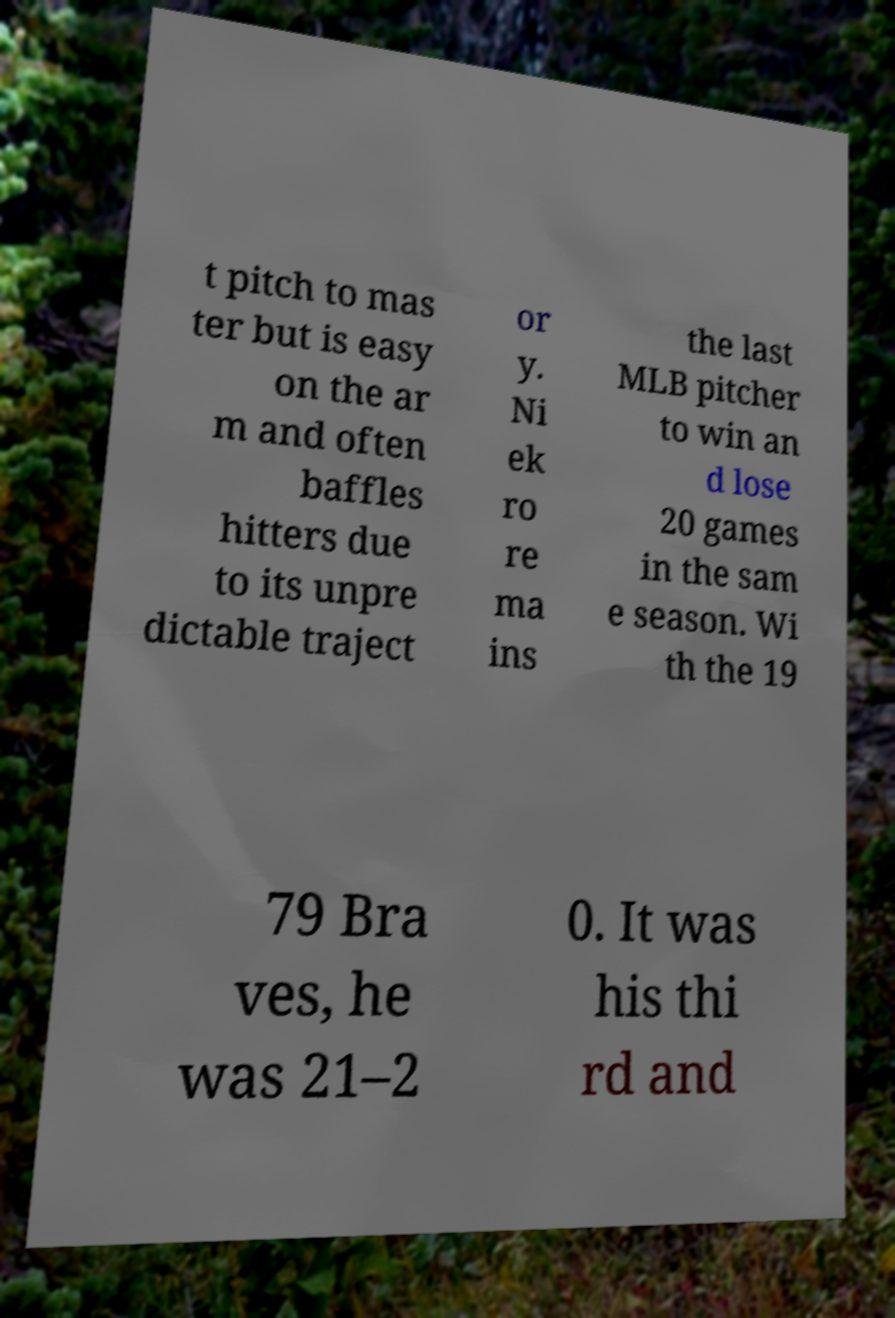What messages or text are displayed in this image? I need them in a readable, typed format. t pitch to mas ter but is easy on the ar m and often baffles hitters due to its unpre dictable traject or y. Ni ek ro re ma ins the last MLB pitcher to win an d lose 20 games in the sam e season. Wi th the 19 79 Bra ves, he was 21–2 0. It was his thi rd and 